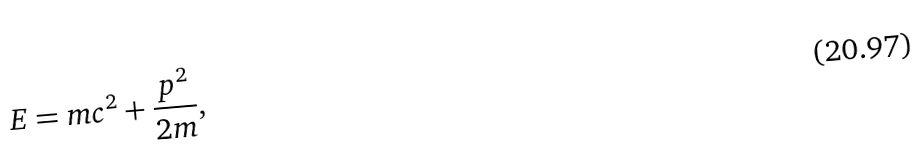Convert formula to latex. <formula><loc_0><loc_0><loc_500><loc_500>E = m c ^ { 2 } + \frac { p ^ { 2 } } { 2 m } ,</formula> 